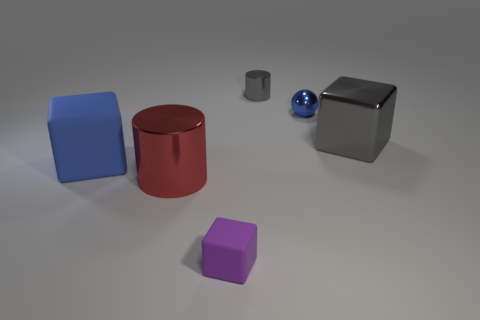Is the number of matte things to the left of the tiny purple matte block greater than the number of big rubber balls?
Your response must be concise. Yes. How many tiny rubber objects are on the left side of the purple matte thing?
Give a very brief answer. 0. There is a large shiny thing that is the same color as the tiny cylinder; what shape is it?
Offer a terse response. Cube. Is there a tiny purple block that is on the left side of the tiny thing that is in front of the large shiny object to the left of the purple matte block?
Provide a short and direct response. No. Does the red metallic thing have the same size as the purple matte cube?
Your answer should be compact. No. Are there an equal number of purple rubber cubes that are on the right side of the purple cube and tiny metallic cylinders that are on the right side of the large gray object?
Provide a succinct answer. Yes. What is the shape of the gray object that is behind the tiny metallic ball?
Offer a very short reply. Cylinder. The rubber object that is the same size as the gray cube is what shape?
Your response must be concise. Cube. What color is the large cube that is on the right side of the matte object to the right of the large object that is in front of the large blue rubber cube?
Your answer should be very brief. Gray. Is the large red thing the same shape as the large blue object?
Make the answer very short. No. 